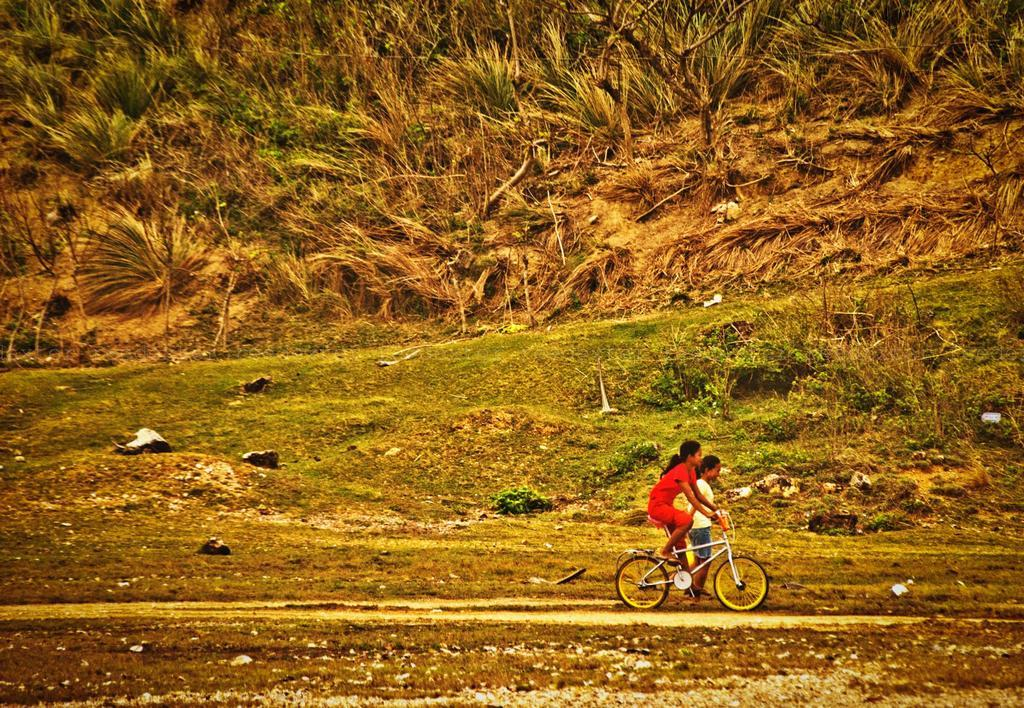What is the girl doing in the image? The girl is sitting on a bicycle in the image. What is the boy doing in the image? The boy is standing on the ground in the image. What can be seen in the background of the image? There are trees, plants, grass, and objects on the ground visible in the background of the image. What type of square is visible in the image? There is no square present in the image. Can you see any deer in the image? There are no deer present in the image. 